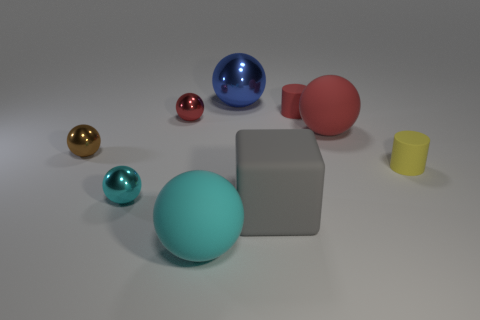What number of objects are either rubber blocks or large yellow metallic balls? In the image, there are several objects present, but it seems there are no objects that match the description of 'rubber blocks' or 'large yellow metallic balls.' Therefore, the number of objects fitting those specific criteria is zero. 